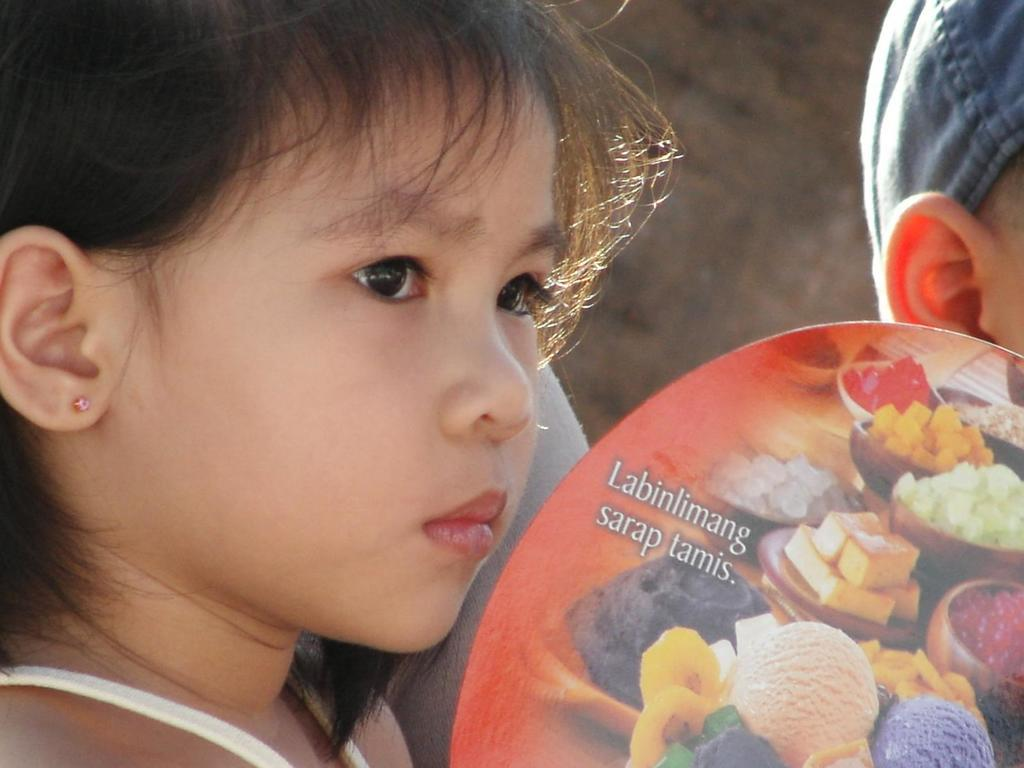What is the main subject of the image? There is a child's face in the image. What time of day is the judge depicted in the image? There is no judge present in the image, and therefore no time of day can be determined for a judge. 